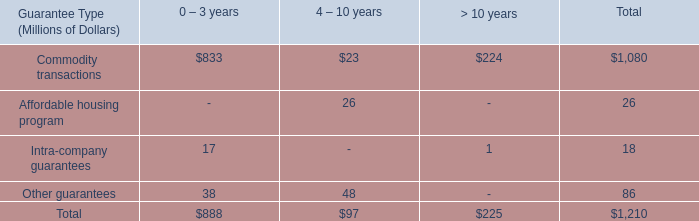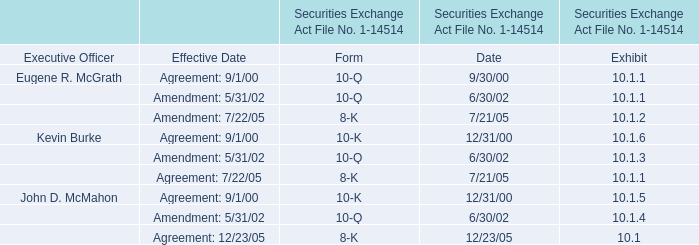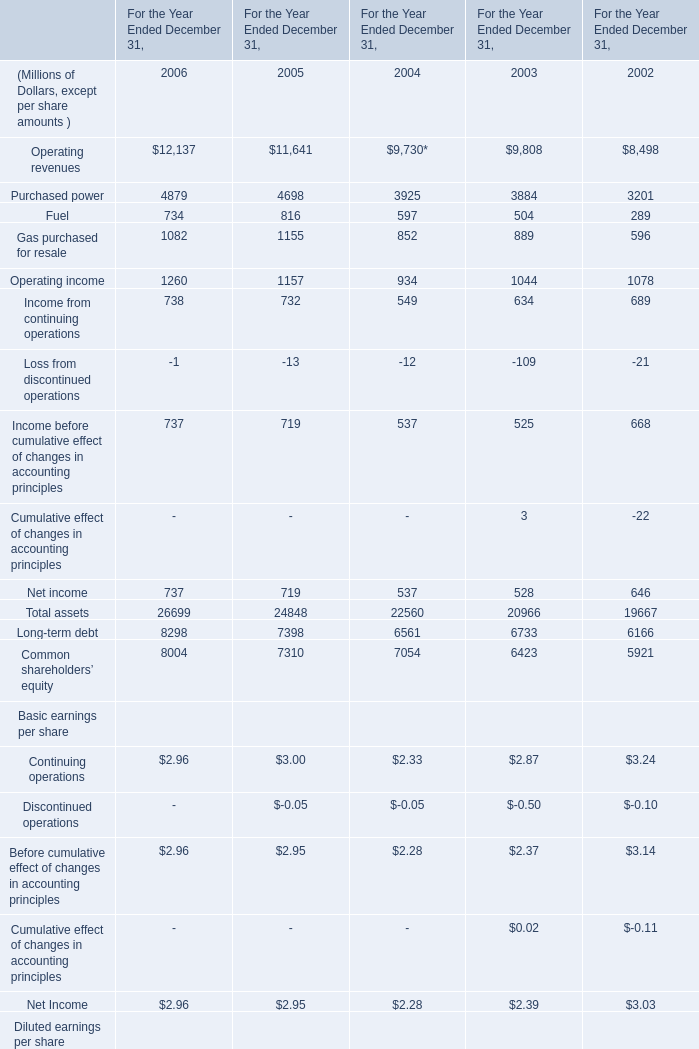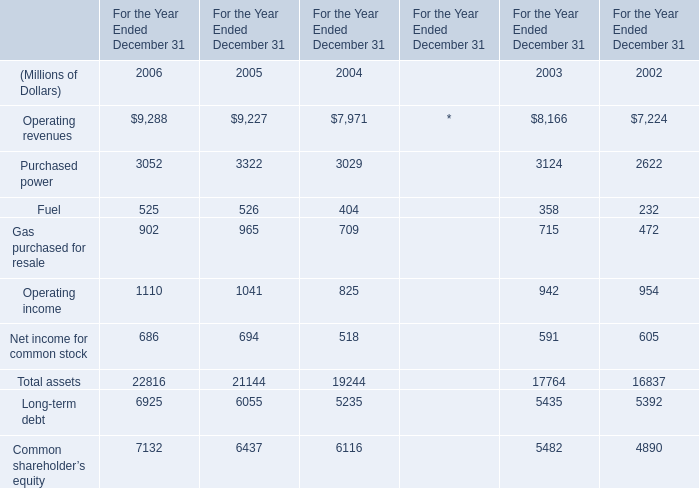What is the average value of Net income in 2004,2005 and 2006? (in million) 
Computations: (((737 + 719) + 537) / 3)
Answer: 664.33333. 